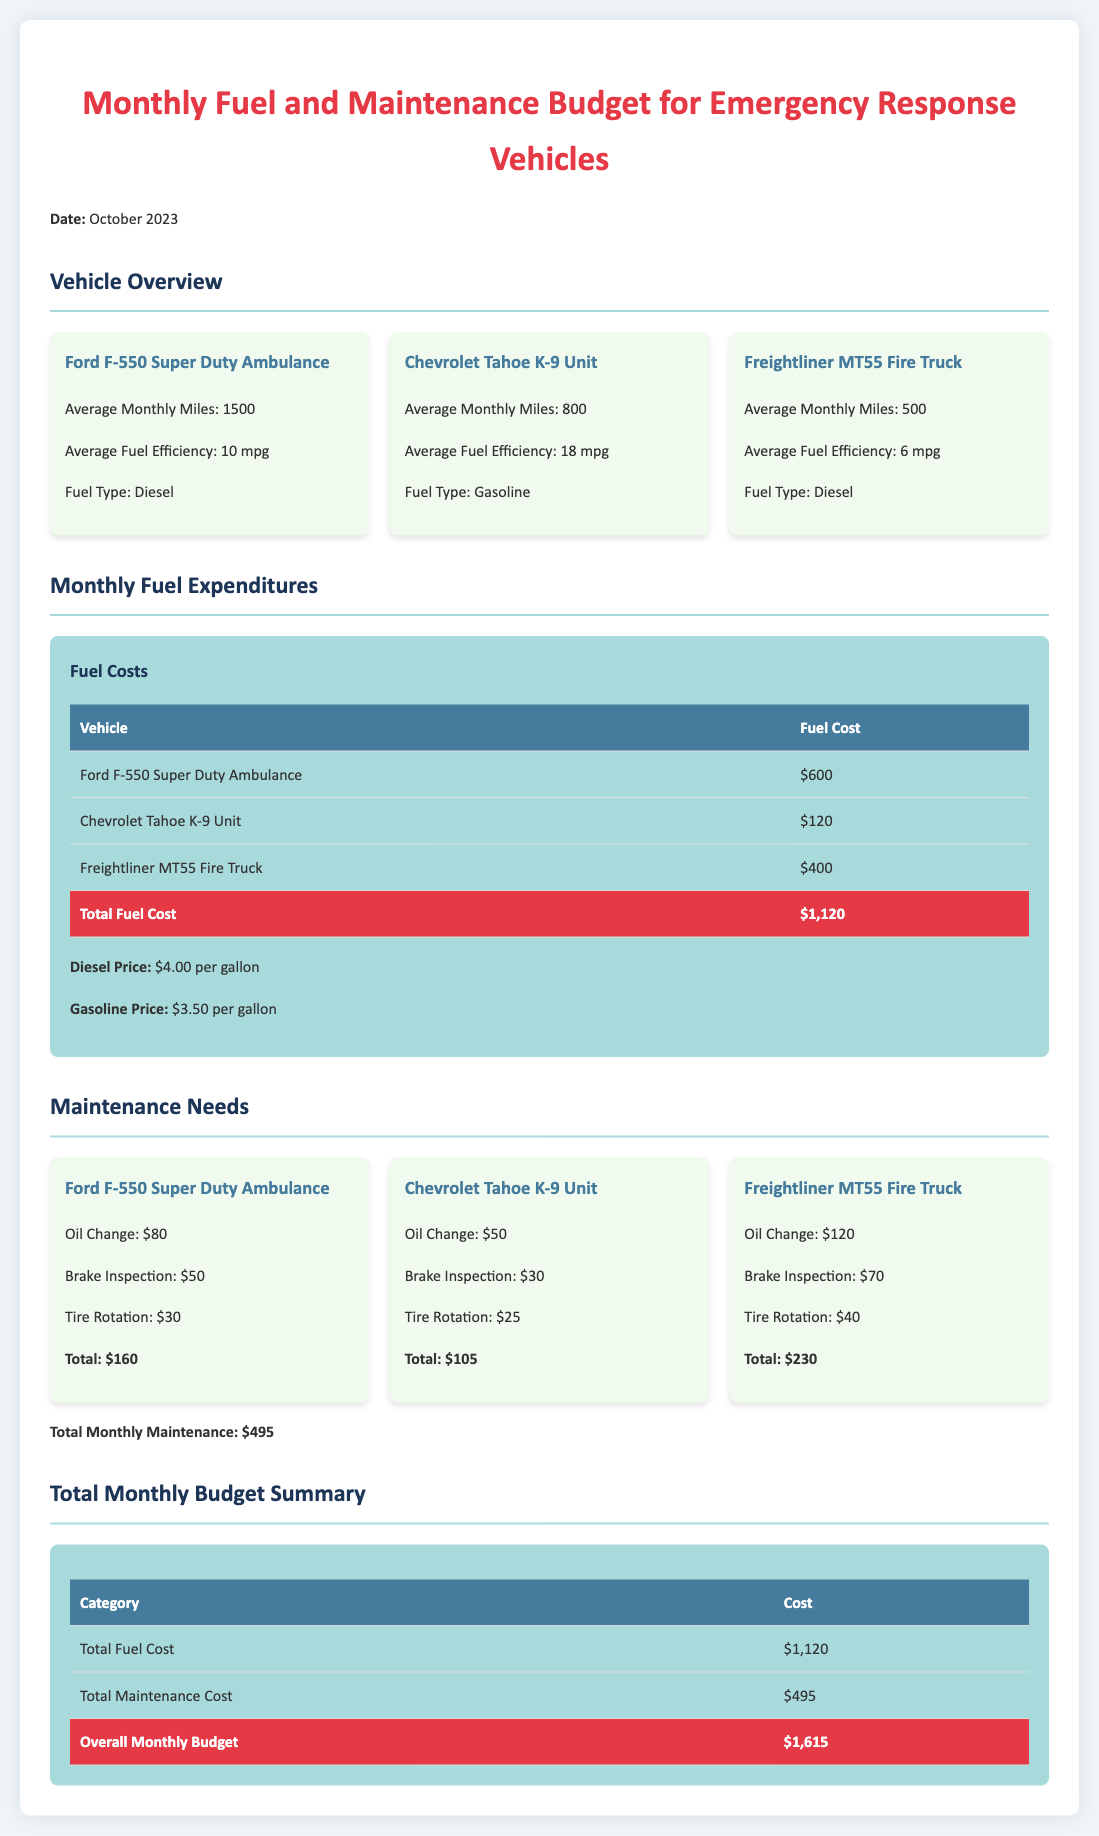What is the total fuel cost for the Ford F-550 Super Duty Ambulance? The fuel cost for the Ford F-550 Super Duty Ambulance is listed in the table, which shows $600.
Answer: $600 What is the average monthly mileage for the Chevrolet Tahoe K-9 Unit? The average monthly mileage for the vehicle is noted as 800 miles in the vehicle overview.
Answer: 800 miles What is the total monthly maintenance cost according to the document? The total monthly maintenance cost is listed at the end of the maintenance section as $495.
Answer: $495 What is the average fuel efficiency of the Freightliner MT55 Fire Truck? The average fuel efficiency is stated as 6 miles per gallon in the vehicle overview.
Answer: 6 mpg What is the total overall monthly budget for all vehicles? The total overall monthly budget is summarized at the bottom of the budget summary as $1,615.
Answer: $1,615 How much does an oil change cost for the Chevrolet Tahoe K-9 Unit? The oil change cost for the vehicle is specified as $50 under the maintenance needs.
Answer: $50 What is the price of gasoline per gallon as noted in the document? The document specifies the gasoline price as $3.50 per gallon in the fuel expenditures section.
Answer: $3.50 How much does it cost to run the Ford F-550 Super Duty Ambulance for fuel? The fuel cost for running the ambulance is detailed in the expenditures section as $600.
Answer: $600 Which vehicle has the highest maintenance cost? The highest maintenance cost is associated with the Freightliner MT55 Fire Truck, which totals $230.
Answer: Freightliner MT55 Fire Truck 